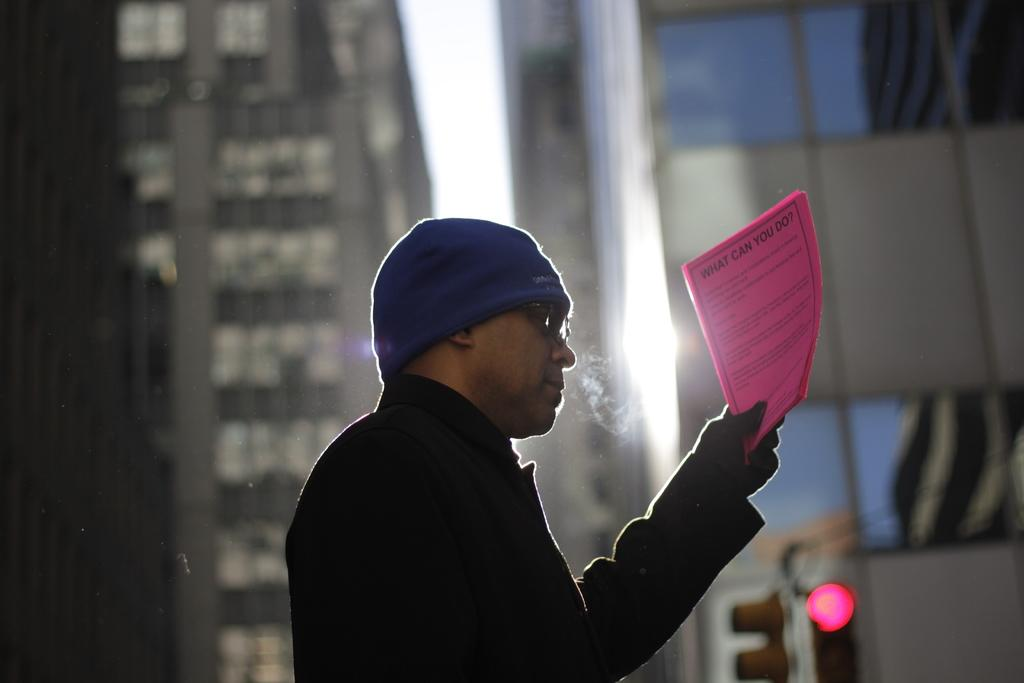What is the person in the image holding? The person is holding papers in the image. What can be seen in the background behind the person? There are buildings visible behind the person. What is visible at the top of the image? The sky is visible at the top of the image. What type of meat is being cooked in the image? There is no meat or cooking activity present in the image. How does the person in the image interact with the bit? There is no bit present in the image, and the person is not interacting with any such object. 